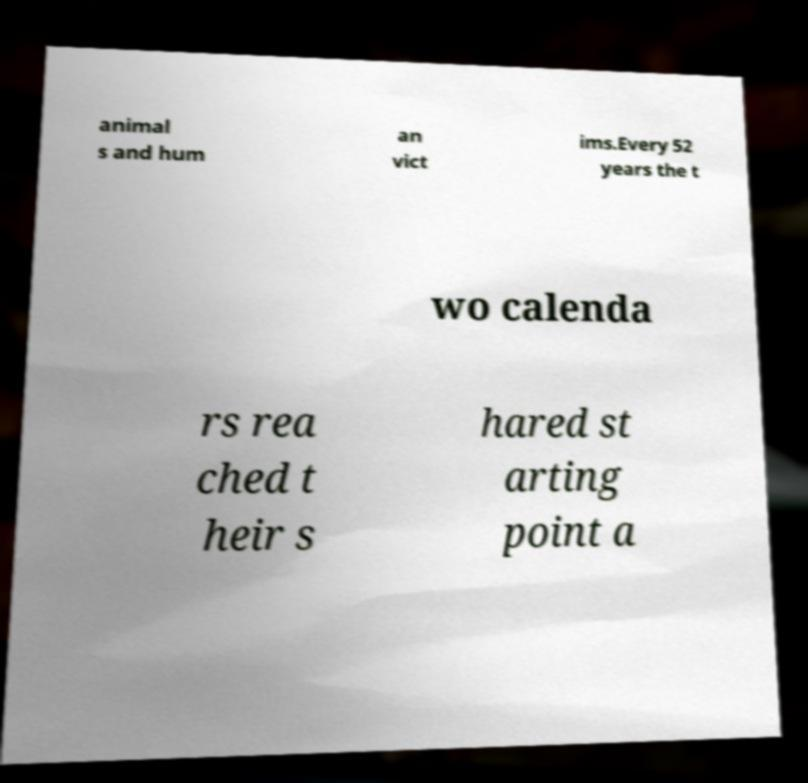Can you accurately transcribe the text from the provided image for me? animal s and hum an vict ims.Every 52 years the t wo calenda rs rea ched t heir s hared st arting point a 